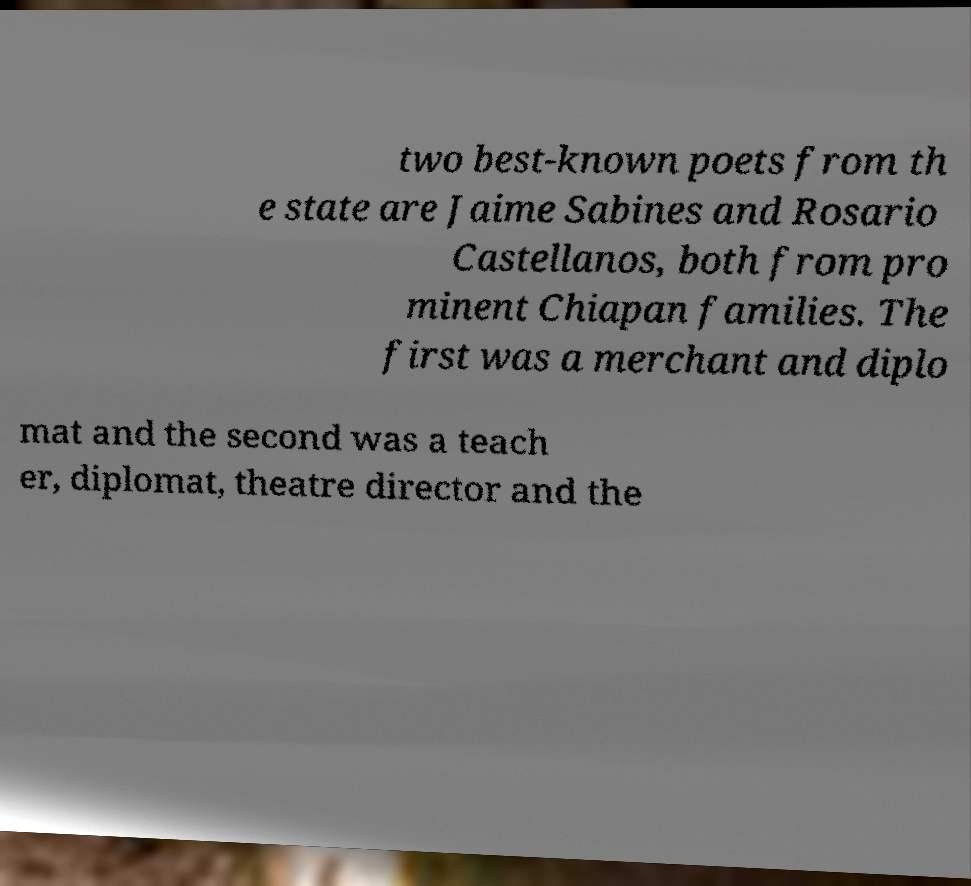Please read and relay the text visible in this image. What does it say? two best-known poets from th e state are Jaime Sabines and Rosario Castellanos, both from pro minent Chiapan families. The first was a merchant and diplo mat and the second was a teach er, diplomat, theatre director and the 